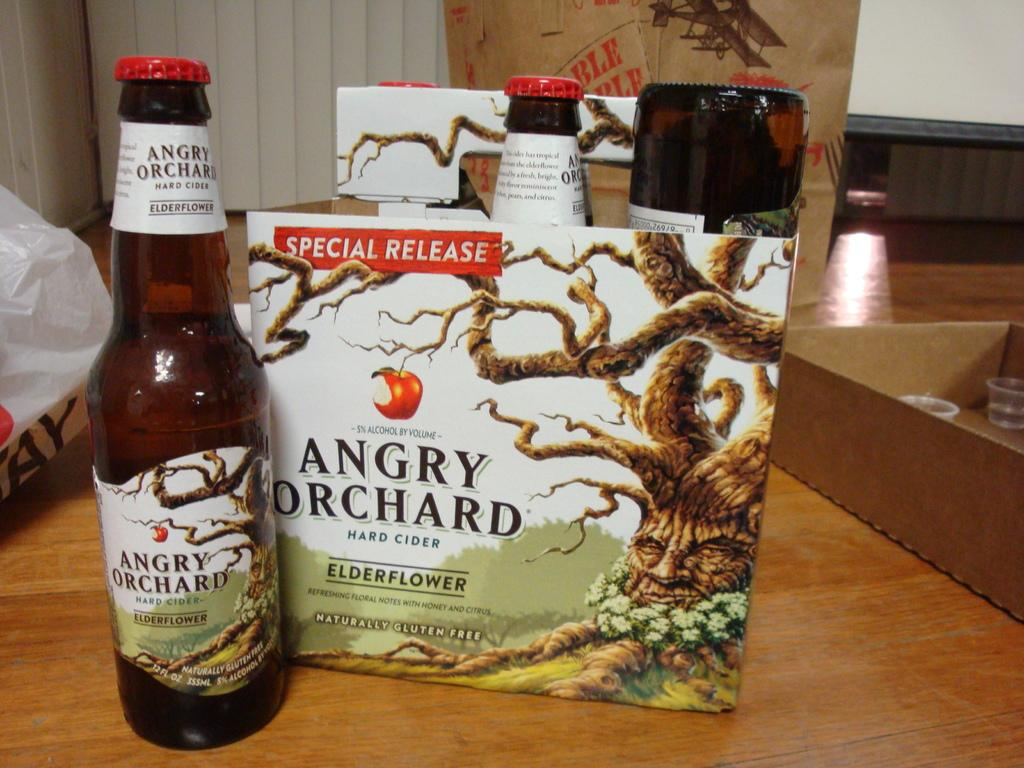What is the main piece of furniture in the image? There is a table in the image. What is placed on the table? There are bottles in a box on the table, and there is another bottle beside the box. Can you describe any other objects in the image? There are a few other objects in the image, but their specific details are not mentioned in the provided facts. What type of silverware is being used by the dolls in the image? There are no dolls or silverware present in the image. 